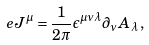Convert formula to latex. <formula><loc_0><loc_0><loc_500><loc_500>e J ^ { \mu } = \frac { 1 } { 2 \pi } \epsilon ^ { \mu \nu \lambda } \partial _ { \nu } A _ { \lambda } \, ,</formula> 